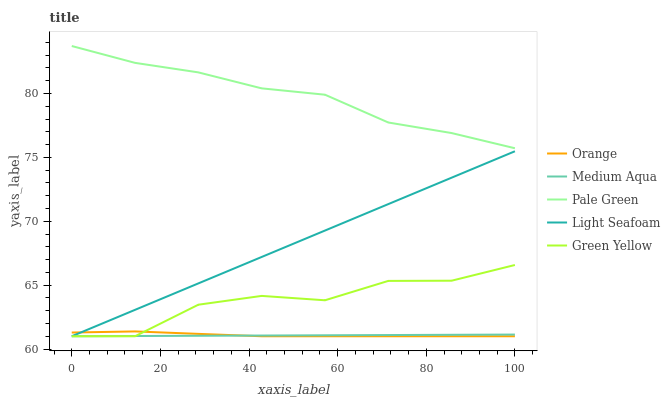Does Medium Aqua have the minimum area under the curve?
Answer yes or no. Yes. Does Pale Green have the maximum area under the curve?
Answer yes or no. Yes. Does Green Yellow have the minimum area under the curve?
Answer yes or no. No. Does Green Yellow have the maximum area under the curve?
Answer yes or no. No. Is Light Seafoam the smoothest?
Answer yes or no. Yes. Is Green Yellow the roughest?
Answer yes or no. Yes. Is Pale Green the smoothest?
Answer yes or no. No. Is Pale Green the roughest?
Answer yes or no. No. Does Orange have the lowest value?
Answer yes or no. Yes. Does Pale Green have the lowest value?
Answer yes or no. No. Does Pale Green have the highest value?
Answer yes or no. Yes. Does Green Yellow have the highest value?
Answer yes or no. No. Is Orange less than Pale Green?
Answer yes or no. Yes. Is Pale Green greater than Medium Aqua?
Answer yes or no. Yes. Does Green Yellow intersect Medium Aqua?
Answer yes or no. Yes. Is Green Yellow less than Medium Aqua?
Answer yes or no. No. Is Green Yellow greater than Medium Aqua?
Answer yes or no. No. Does Orange intersect Pale Green?
Answer yes or no. No. 